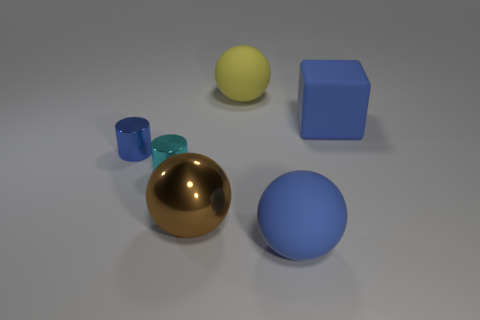Can you describe the shapes of the objects in the image? Certainly! There's a large gold sphere, a small yellow sphere, a medium blue sphere, a small teal cylinder, and a larger teal cylinder. Additionally, there's a cube with a blue color. 